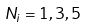<formula> <loc_0><loc_0><loc_500><loc_500>N _ { i } = 1 , 3 , 5</formula> 